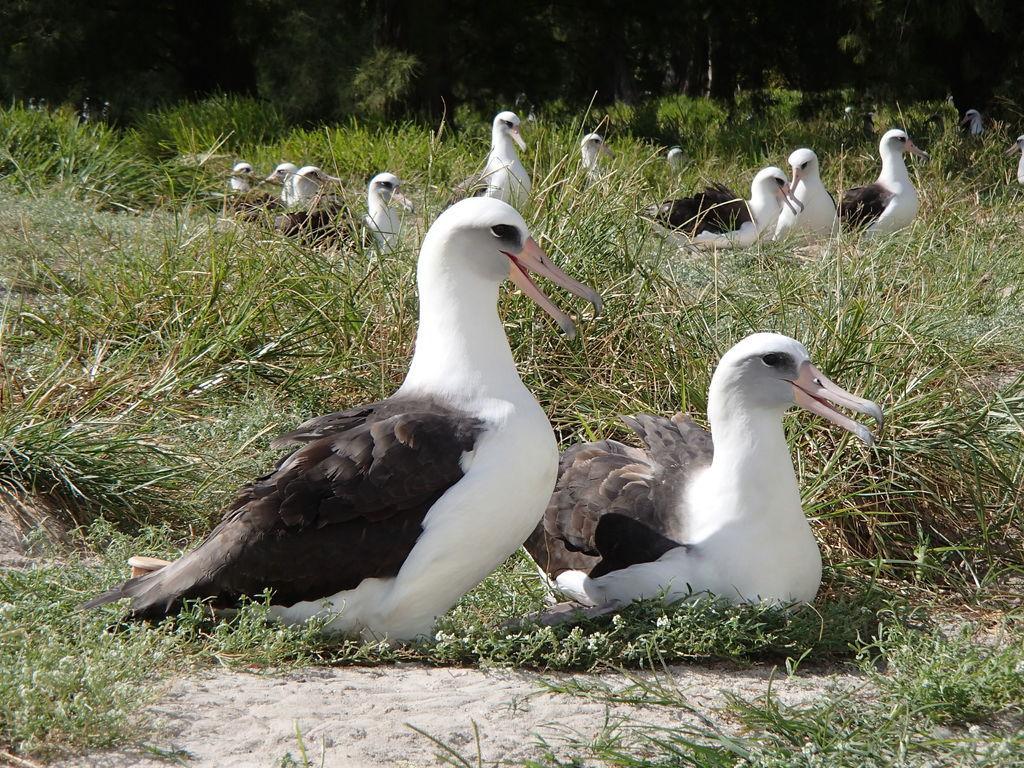Please provide a concise description of this image. In this picture we can observe ducks which are in white and black color on the ground. There is some grass on the ground. In the background there are trees. 